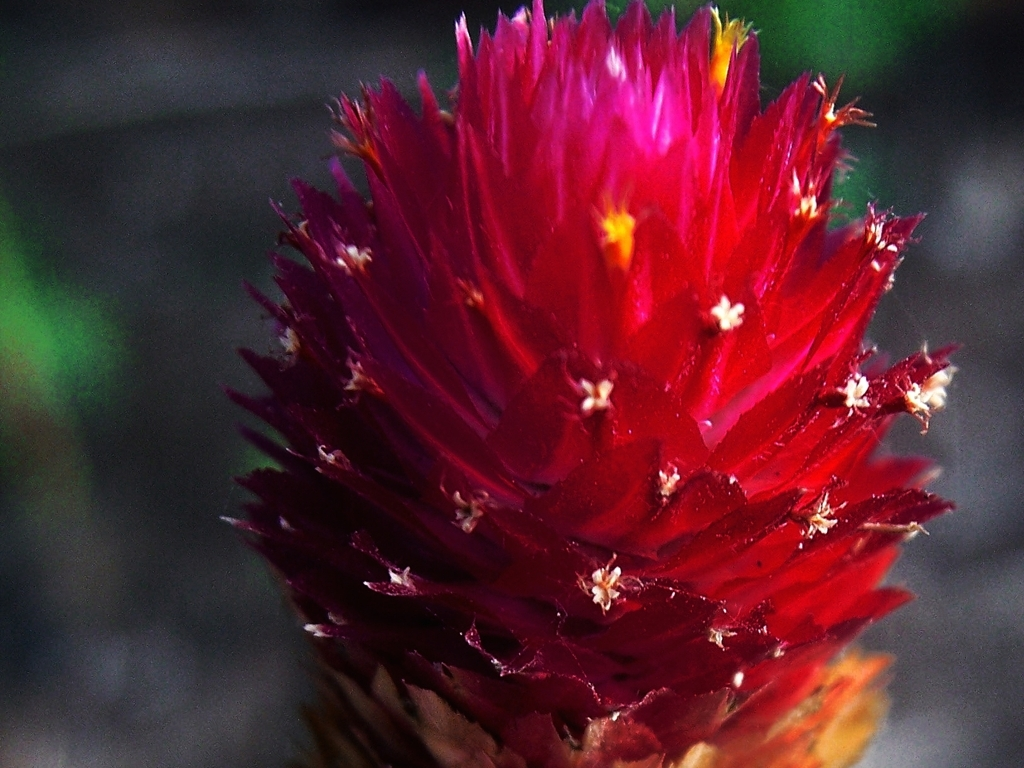Can you speculate about the geographical location this plant is native to, based on its appearance? The plant's vibrant coloration and flowering habit suggest it thrives in a climate that is mild and possibly temperate. Such plants are often found in regions with well-defined growing seasons, where they can fully develop their colorful blooms. 